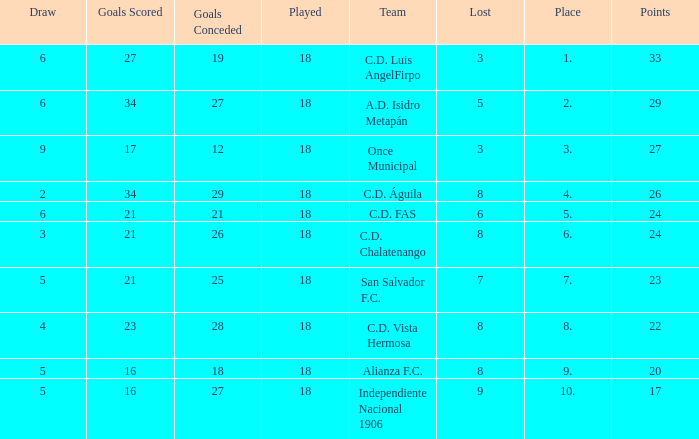What are the number of goals conceded that has a played greater than 18? 0.0. 